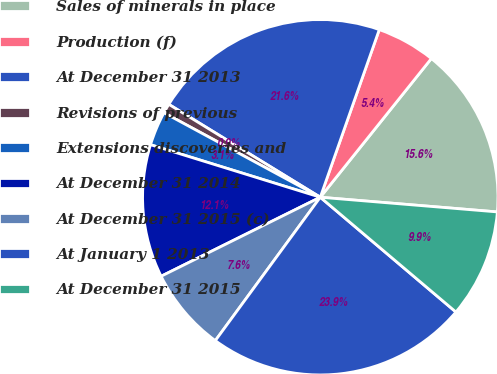Convert chart. <chart><loc_0><loc_0><loc_500><loc_500><pie_chart><fcel>Sales of minerals in place<fcel>Production (f)<fcel>At December 31 2013<fcel>Revisions of previous<fcel>Extensions discoveries and<fcel>At December 31 2014<fcel>At December 31 2015 (c)<fcel>At January 1 2013<fcel>At December 31 2015<nl><fcel>15.57%<fcel>5.36%<fcel>21.63%<fcel>0.87%<fcel>3.11%<fcel>12.11%<fcel>7.61%<fcel>23.88%<fcel>9.86%<nl></chart> 